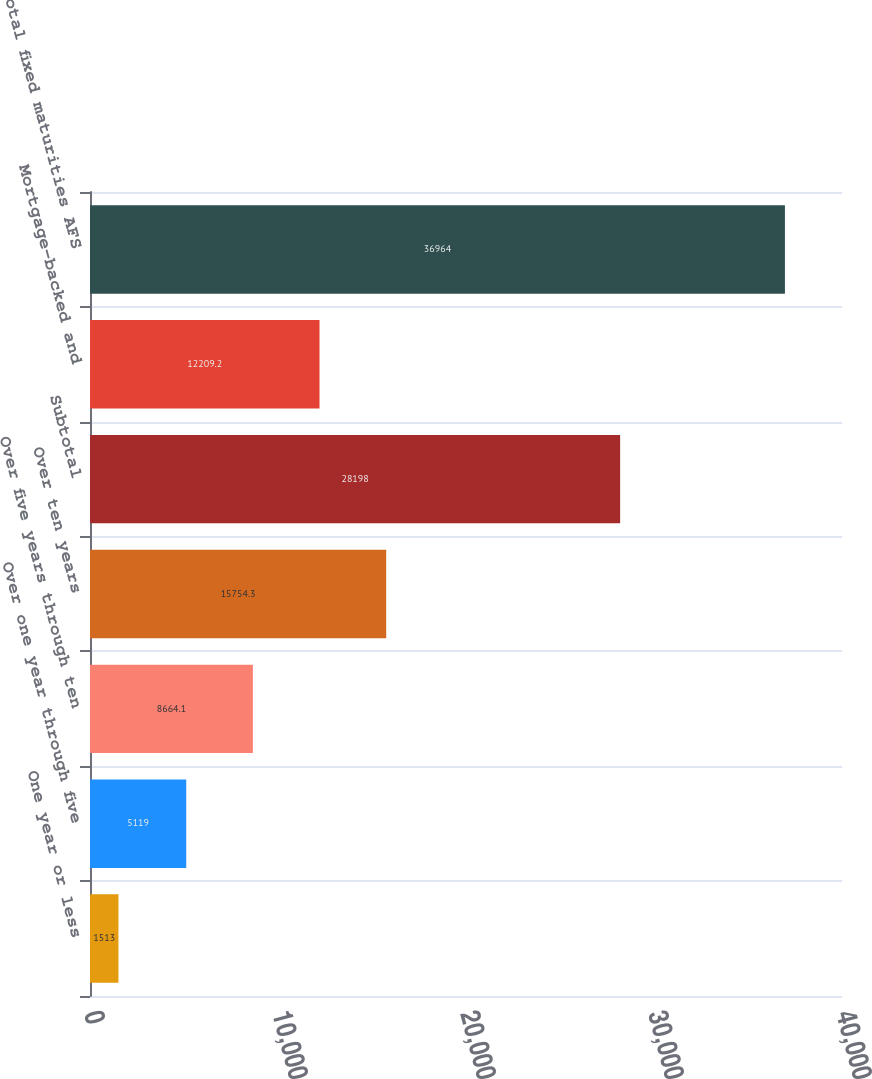Convert chart to OTSL. <chart><loc_0><loc_0><loc_500><loc_500><bar_chart><fcel>One year or less<fcel>Over one year through five<fcel>Over five years through ten<fcel>Over ten years<fcel>Subtotal<fcel>Mortgage-backed and<fcel>Total fixed maturities AFS<nl><fcel>1513<fcel>5119<fcel>8664.1<fcel>15754.3<fcel>28198<fcel>12209.2<fcel>36964<nl></chart> 